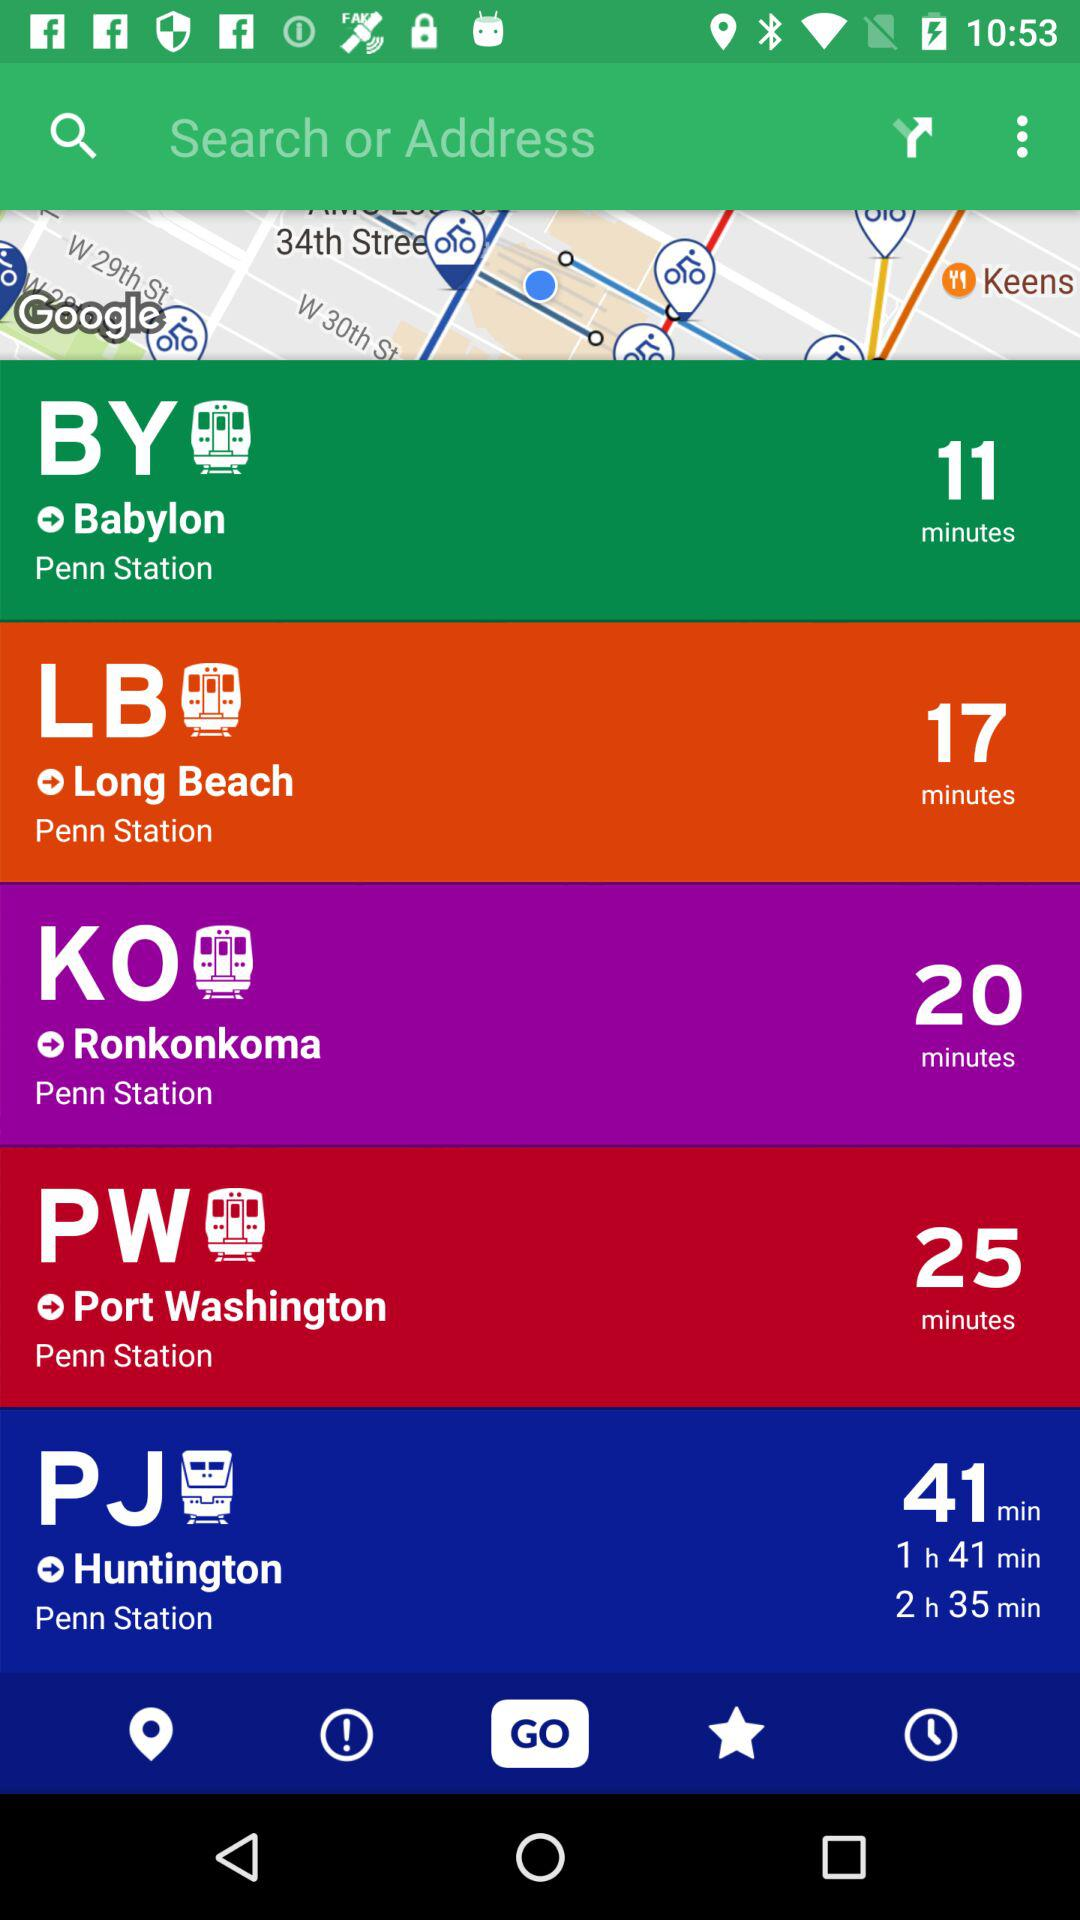How long will it take to reach "Babylon"? It will take 11 minutes to reach "Babylon". 